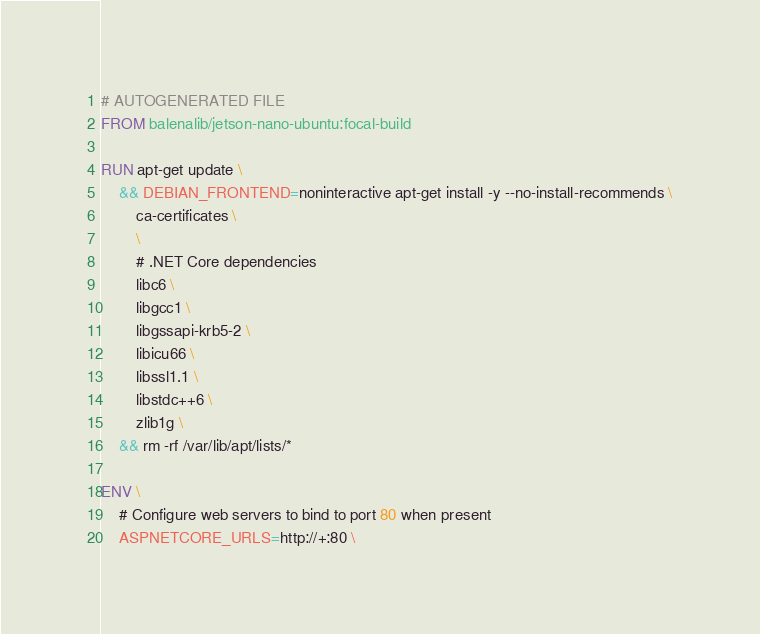<code> <loc_0><loc_0><loc_500><loc_500><_Dockerfile_># AUTOGENERATED FILE
FROM balenalib/jetson-nano-ubuntu:focal-build

RUN apt-get update \
    && DEBIAN_FRONTEND=noninteractive apt-get install -y --no-install-recommends \
        ca-certificates \
        \
        # .NET Core dependencies
        libc6 \
        libgcc1 \
        libgssapi-krb5-2 \
        libicu66 \
        libssl1.1 \
        libstdc++6 \
        zlib1g \
    && rm -rf /var/lib/apt/lists/*

ENV \
    # Configure web servers to bind to port 80 when present
    ASPNETCORE_URLS=http://+:80 \</code> 